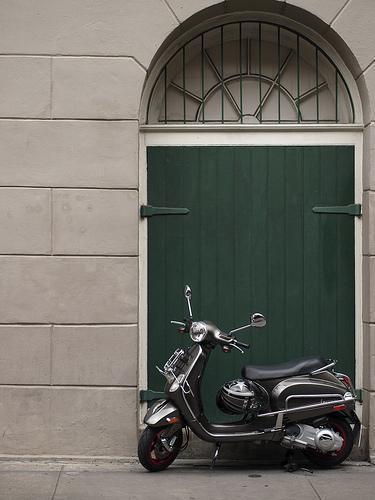How many scooters are there?
Give a very brief answer. 1. 